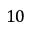Convert formula to latex. <formula><loc_0><loc_0><loc_500><loc_500>1 0</formula> 